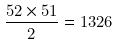Convert formula to latex. <formula><loc_0><loc_0><loc_500><loc_500>\frac { 5 2 \times 5 1 } { 2 } = 1 3 2 6</formula> 